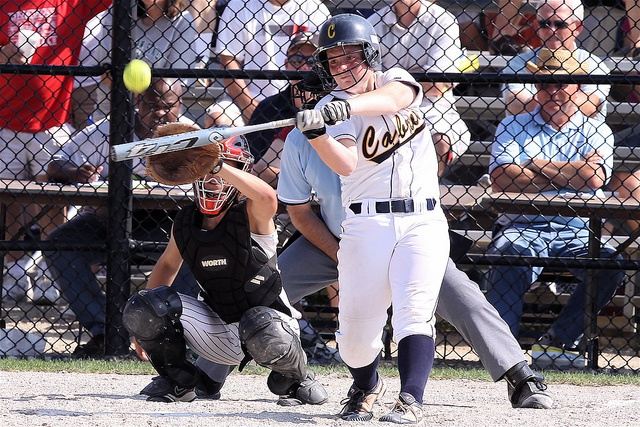Describe the objects in this image and their specific colors. I can see people in maroon, lavender, black, gray, and darkgray tones, people in maroon, black, gray, darkgray, and lightgray tones, people in maroon, black, white, navy, and gray tones, people in maroon, black, brown, and gray tones, and people in maroon, gray, lavender, darkgray, and black tones in this image. 